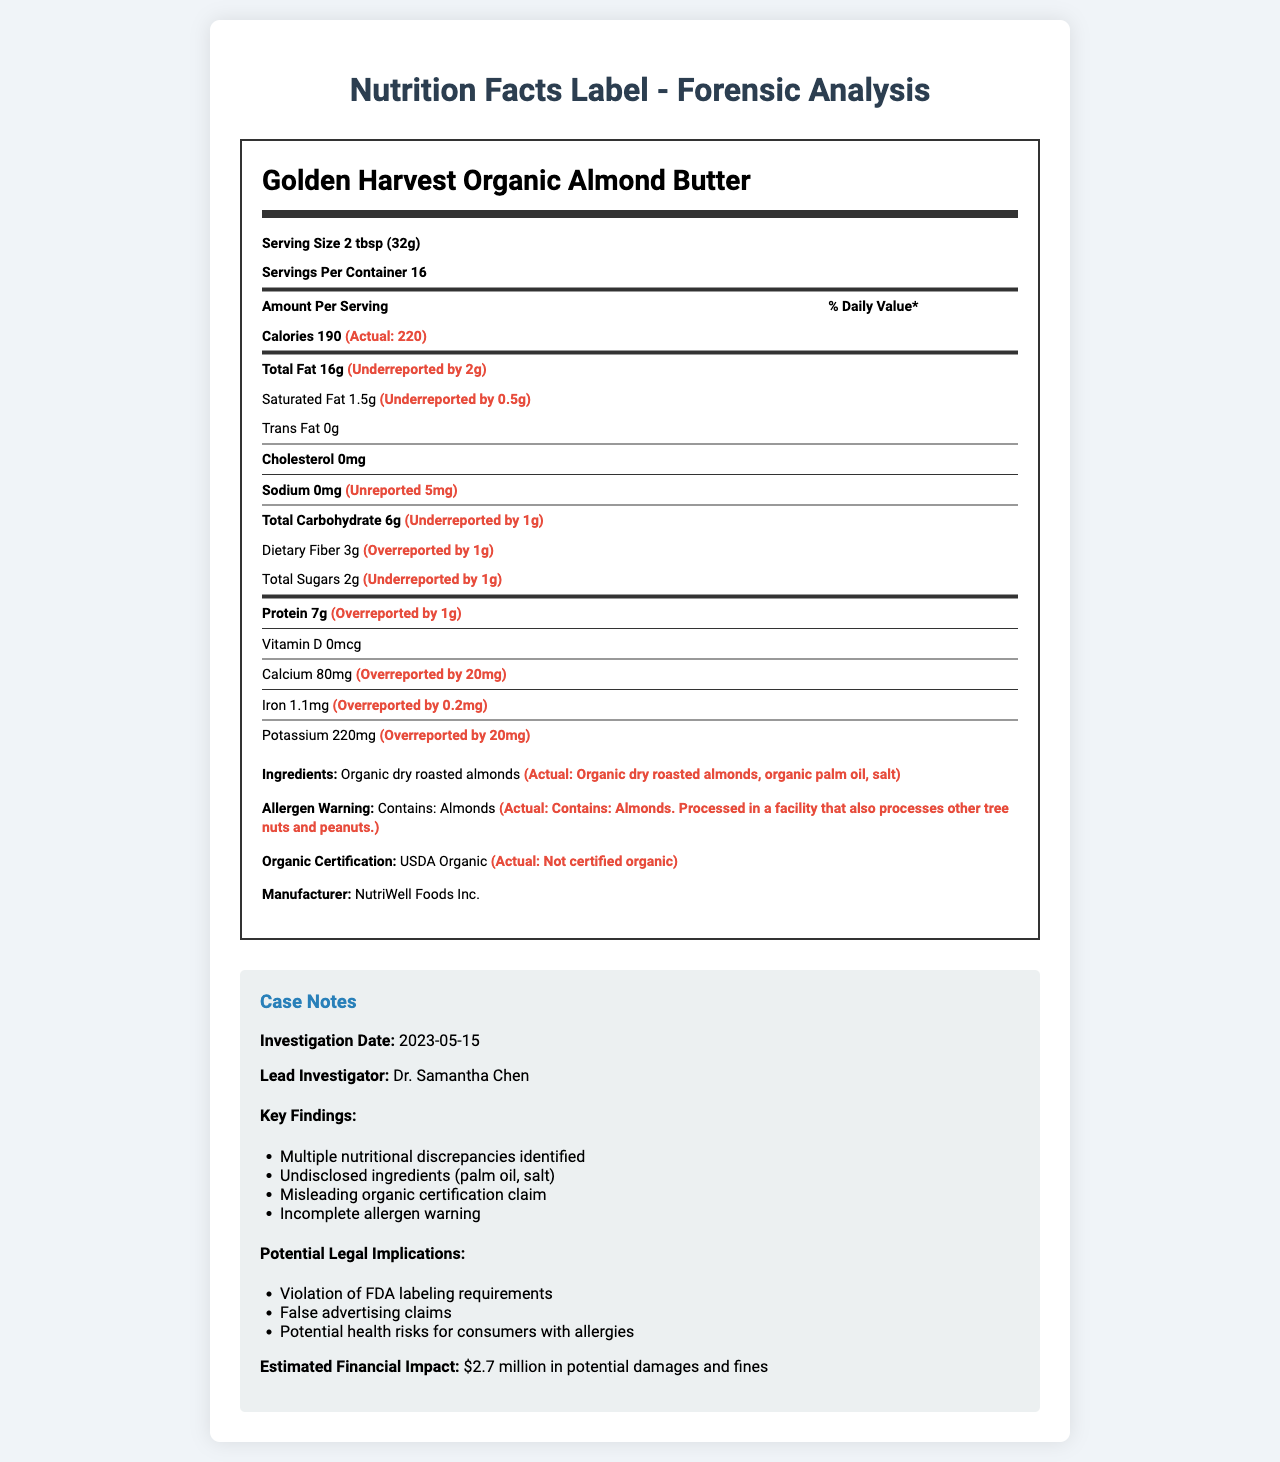what is the actual serving size for Golden Harvest Organic Almond Butter? The document states the serving size as "2 tbsp (32g)".
Answer: 2 tbsp (32g) how many calories are actually in one serving? The document indicates that the actual calories per serving are 220, despite being labeled as 190.
Answer: 220 Identify the discrepancy in the reported and the actual Total Fat content per serving. The label states 16g of Total Fat, but the actual value is 18g.
Answer: Underreported by 2g what ingredient is missing from the label but present in the actual product? The actual ingredients list includes "organic palm oil, salt" which are missing from the label.
Answer: Organic palm oil, salt Is the allergen warning on the label complete? The actual allergen warning specifies that the product is processed in a facility that also processes other tree nuts and peanuts, which is missing from the label.
Answer: No which vitamin's amount is accurately reported on the label? A. Vitamin D B. Calcium C. Iron The document shows that both the labeled and actual amount of Vitamin D is 0mcg.
Answer: A how much total carbohydrate is actually in one serving? The document reports an actual total carbohydrate content of 7g, despite the label listing 6g.
Answer: 7g Identify the line indicating an incorrect organic certification on the label. The document reveals that the product is not certified organic, contradicting the USDA Organic label.
Answer: USDA Organic which of these findings was identified during the forensic investigation? A. Correct serving size B. Misleading organic certification claim C. Absence of allergens The key findings section lists a misleading organic certification claim.
Answer: B summarize the main discrepancies identified in the document. The summary includes all the major discrepancies and issues that were found during the forensic investigation of the product.
Answer: The document reveals discrepancies in nutritional values, undeclared ingredients, misleading organic certification, and incomplete allergen warnings. how much was dietary fiber overreported by on the label? The label states 3g of dietary fiber while the actual amount is 2g.
Answer: Overreported by 1g Describe the financial impact estimated due to these discrepancies. The estimated financial impact section of the case notes specifies this amount.
Answer: $2.7 million in potential damages and fines can the lead investigator’s contact information be found in the document? The document only provides the lead investigator's name, "Dr. Samantha Chen," but no contact details.
Answer: Not enough information Is there any inaccuracy in the reported iron content on the label? The document indicates that iron content was overreported by 0.2mg, from 1.1mg on the label to 0.9mg actually.
Answer: Yes how many discrepancies were identified in total carbohydrate content and dietary fiber? Total carbohydrate was underreported by 1g and dietary fiber was overreported by 1g, making it two discrepancies.
Answer: Two discrepancies 